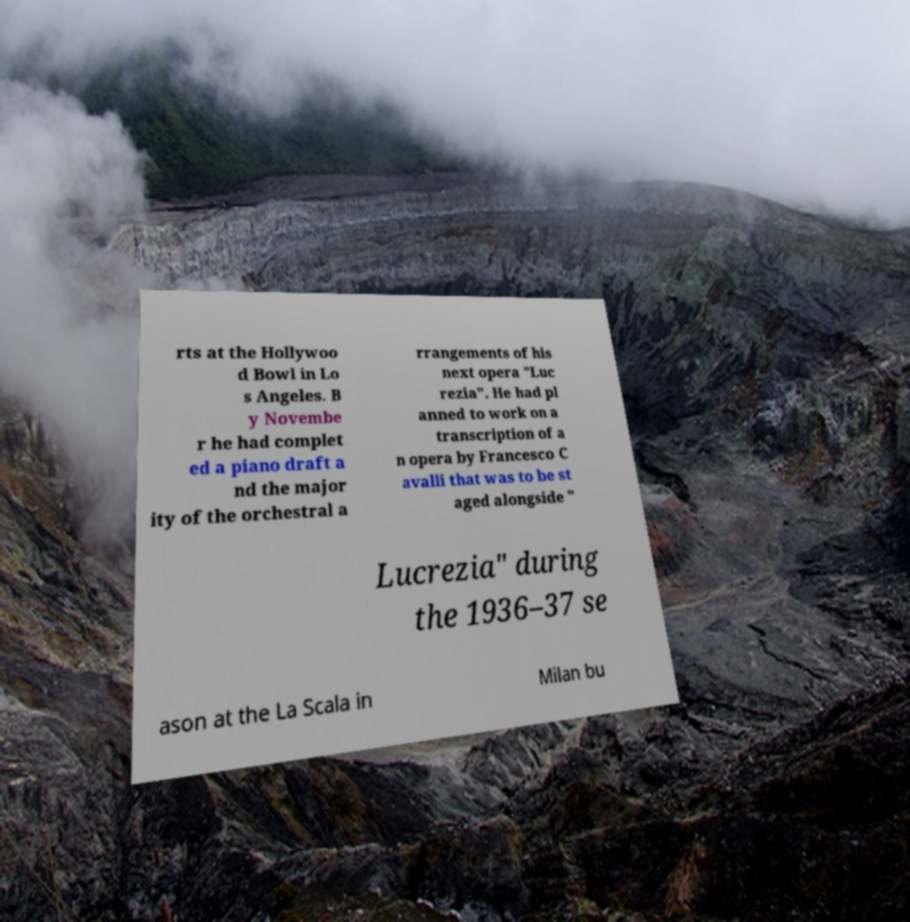Could you assist in decoding the text presented in this image and type it out clearly? rts at the Hollywoo d Bowl in Lo s Angeles. B y Novembe r he had complet ed a piano draft a nd the major ity of the orchestral a rrangements of his next opera "Luc rezia". He had pl anned to work on a transcription of a n opera by Francesco C avalli that was to be st aged alongside " Lucrezia" during the 1936–37 se ason at the La Scala in Milan bu 